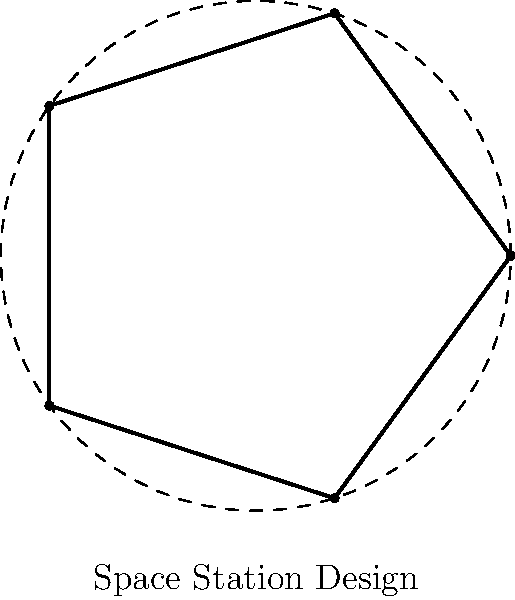In the futuristic space station design shown above, the structure is based on a regular pentagon. If one of the interior angles of this pentagon is 108°, what is the measure of the central angle formed by two adjacent vertices and the center of the pentagon? Let's approach this step-by-step:

1) First, recall that the sum of interior angles of any polygon with $n$ sides is given by the formula:
   $$(n-2) \times 180°$$

2) For a pentagon, $n = 5$, so the sum of interior angles is:
   $$(5-2) \times 180° = 3 \times 180° = 540°$$

3) In a regular pentagon, all interior angles are equal. We're given that each interior angle is 108°. We can verify this:
   $$540° \div 5 = 108°$$

4) Now, let's consider the central angle. In any regular polygon, the central angles form a complete circle (360°) and are all equal.

5) The number of central angles is equal to the number of sides of the polygon. In this case, there are 5 central angles.

6) Therefore, each central angle measures:
   $$360° \div 5 = 72°$$

This result can also be derived from the fact that in any regular polygon, the measure of a central angle is supplementary to the measure of an interior angle:
   $$180° - 108° = 72°$$

Thus, the measure of the central angle formed by two adjacent vertices and the center of the pentagon is 72°.
Answer: 72° 